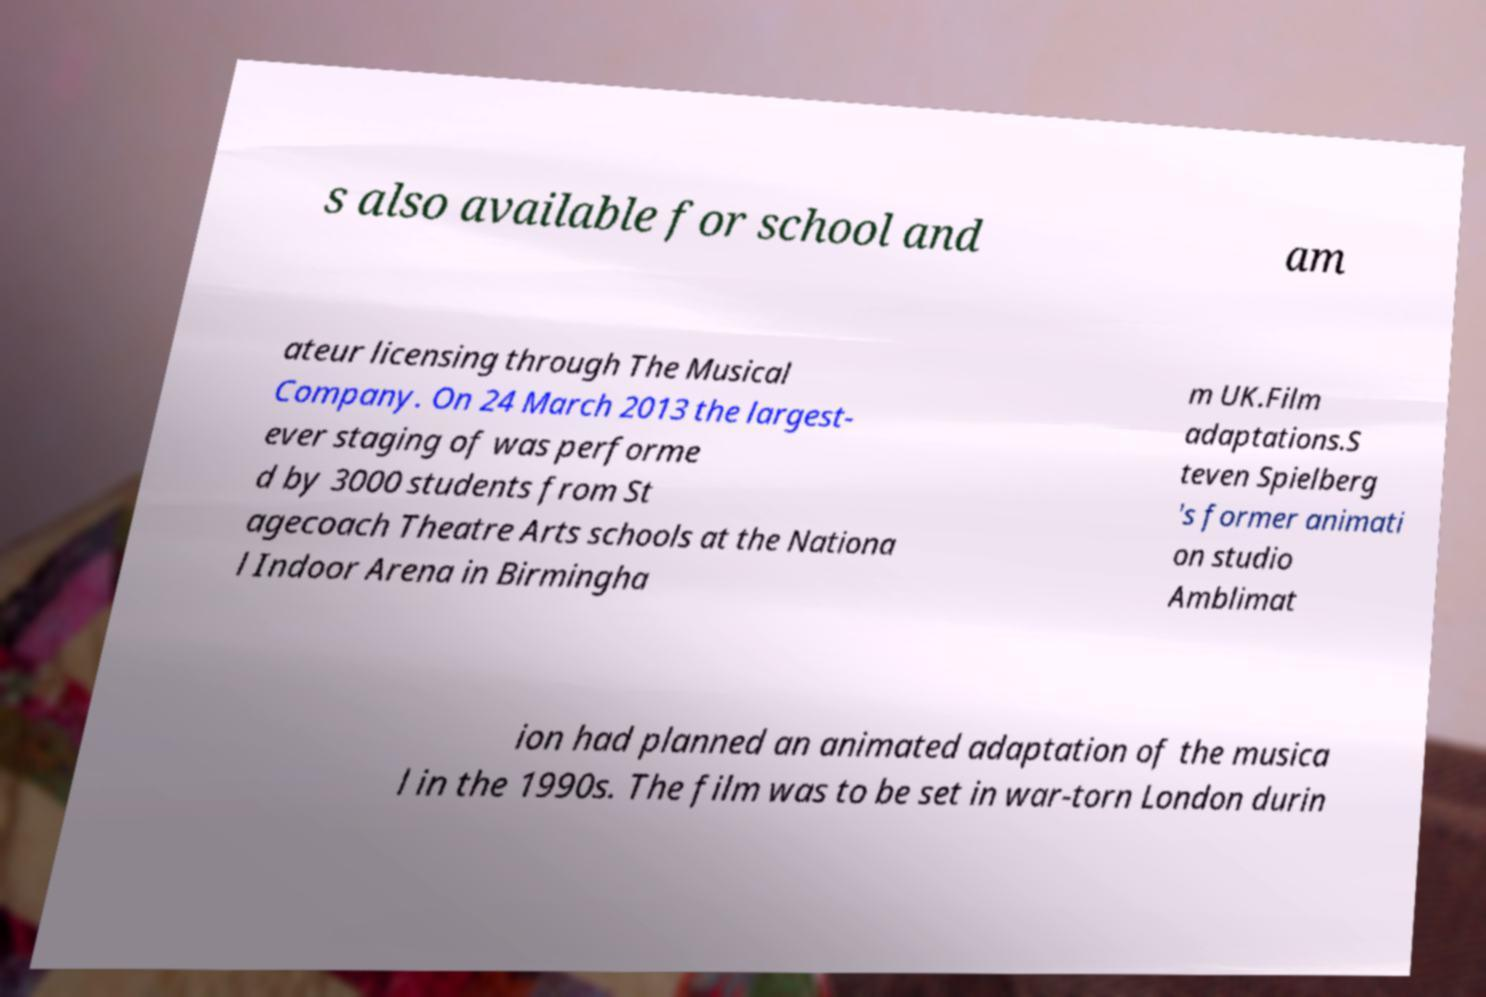I need the written content from this picture converted into text. Can you do that? s also available for school and am ateur licensing through The Musical Company. On 24 March 2013 the largest- ever staging of was performe d by 3000 students from St agecoach Theatre Arts schools at the Nationa l Indoor Arena in Birmingha m UK.Film adaptations.S teven Spielberg 's former animati on studio Amblimat ion had planned an animated adaptation of the musica l in the 1990s. The film was to be set in war-torn London durin 